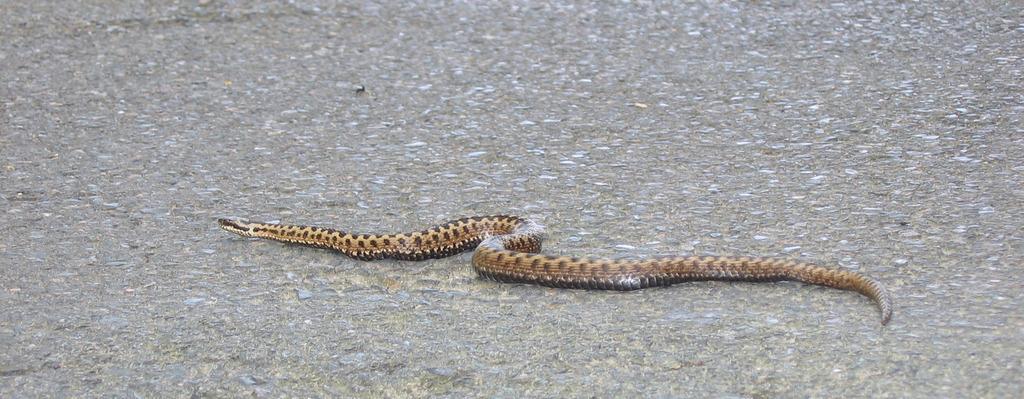Could you give a brief overview of what you see in this image? In this picture there is a snake on the road. 